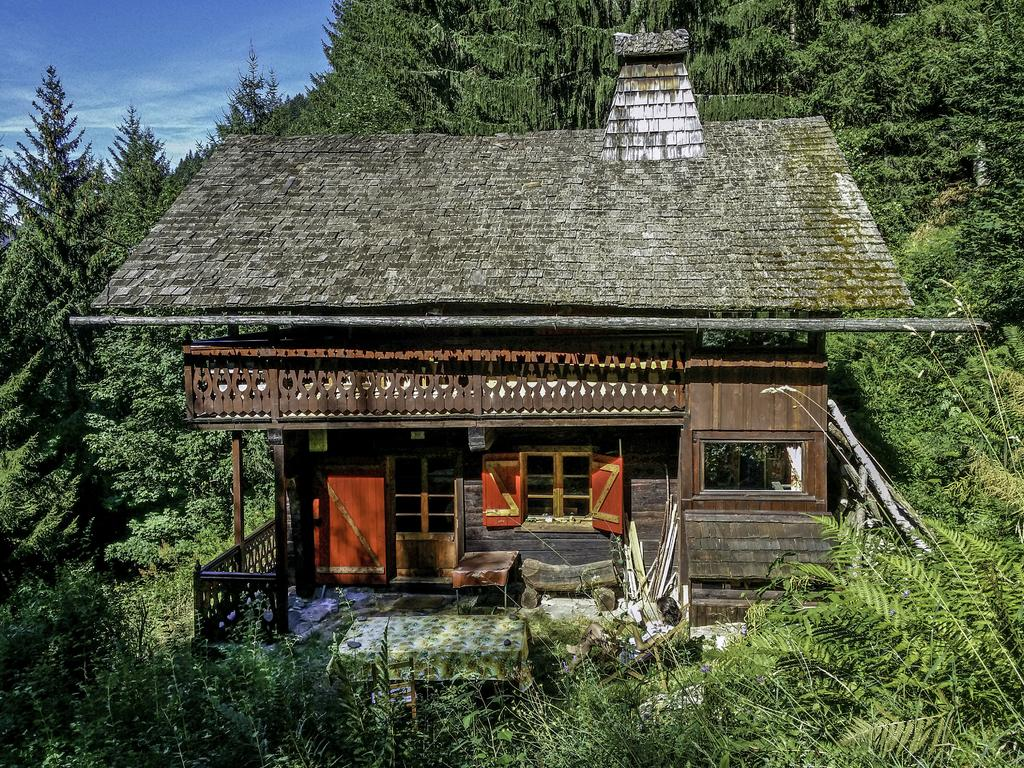What type of house is in the image? There is a small wooden roof house in the image. Where is the house located? The house is located in a forest. What color is the door on the house? The door on the house is red. How many windows are visible on the house? There is one window visible on the house. What is above the window on the house? There is a wooden grill above the window. What can be seen in the background of the image? There are trees visible in the background of the image. What type of range can be seen in the image? There is no range present in the image; it features a small wooden roof house in a forest. What is the milk used for in the image? There is no milk present in the image, so its use cannot be determined. 